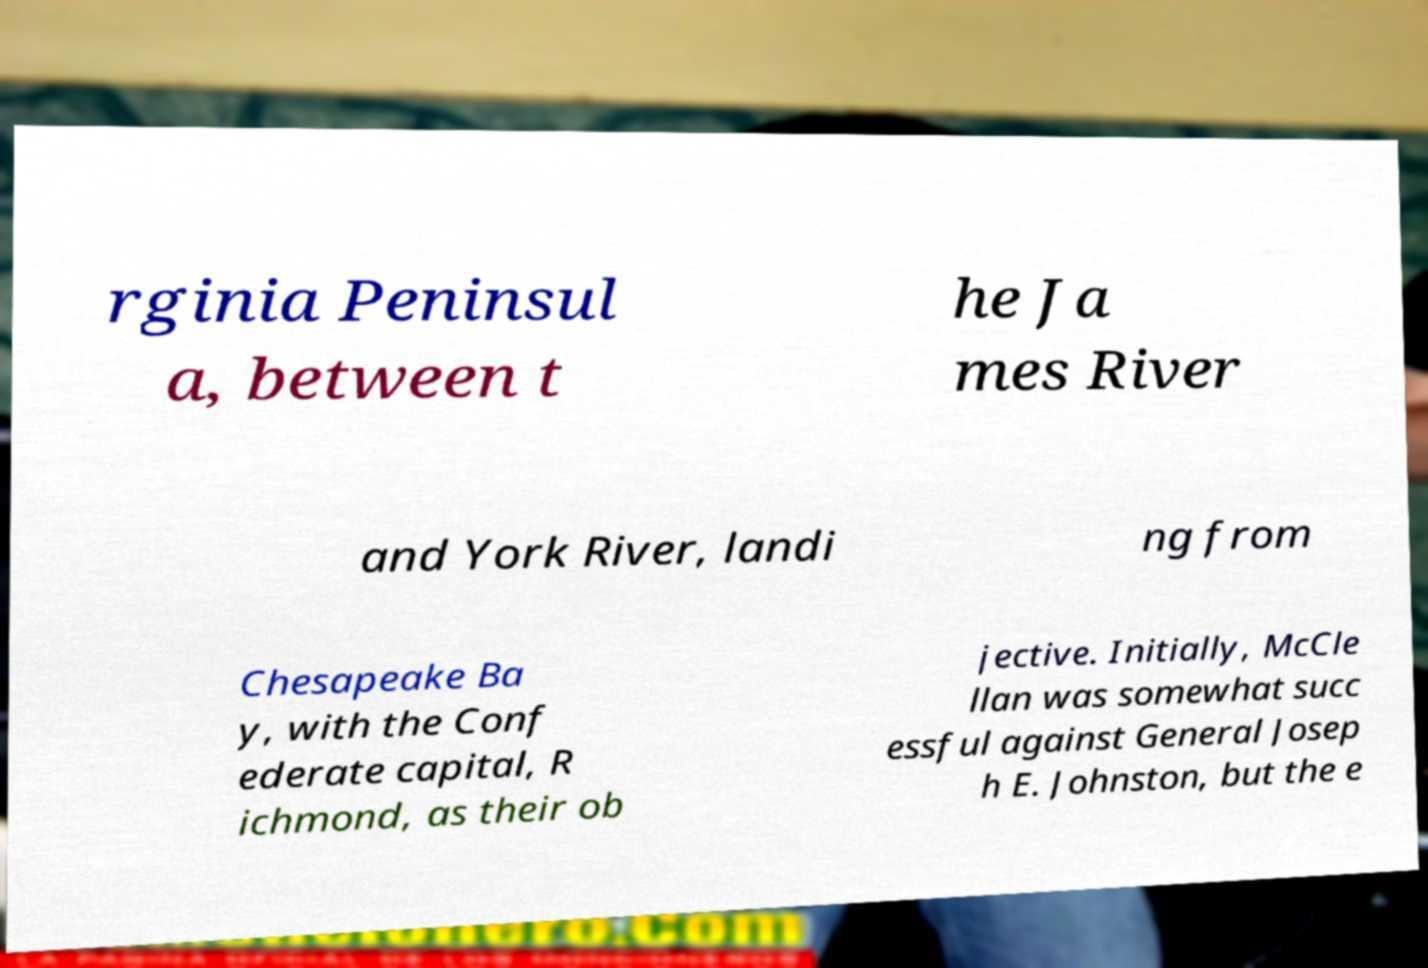Please read and relay the text visible in this image. What does it say? rginia Peninsul a, between t he Ja mes River and York River, landi ng from Chesapeake Ba y, with the Conf ederate capital, R ichmond, as their ob jective. Initially, McCle llan was somewhat succ essful against General Josep h E. Johnston, but the e 